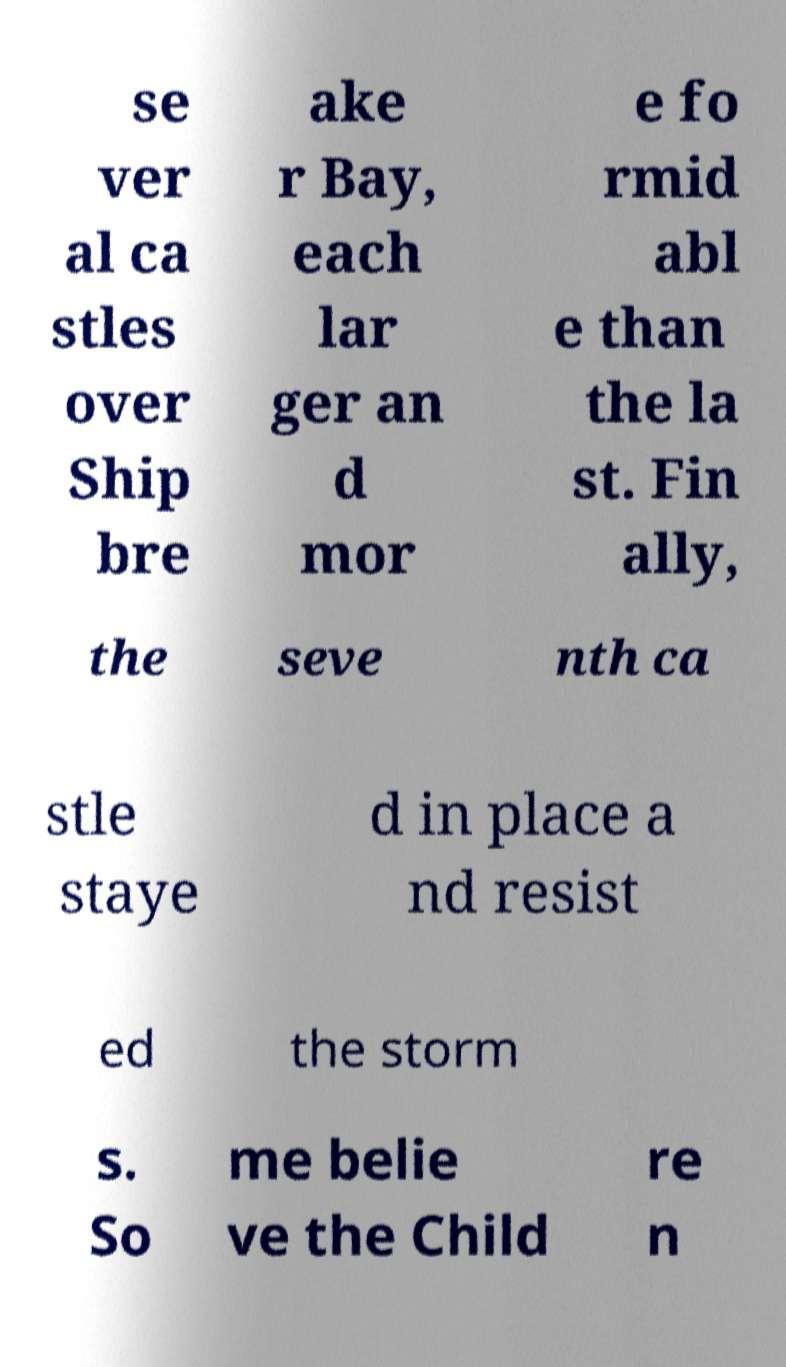Could you assist in decoding the text presented in this image and type it out clearly? se ver al ca stles over Ship bre ake r Bay, each lar ger an d mor e fo rmid abl e than the la st. Fin ally, the seve nth ca stle staye d in place a nd resist ed the storm s. So me belie ve the Child re n 